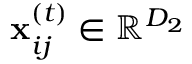Convert formula to latex. <formula><loc_0><loc_0><loc_500><loc_500>x _ { i j } ^ { ( t ) } \in \mathbb { R } ^ { D _ { 2 } }</formula> 